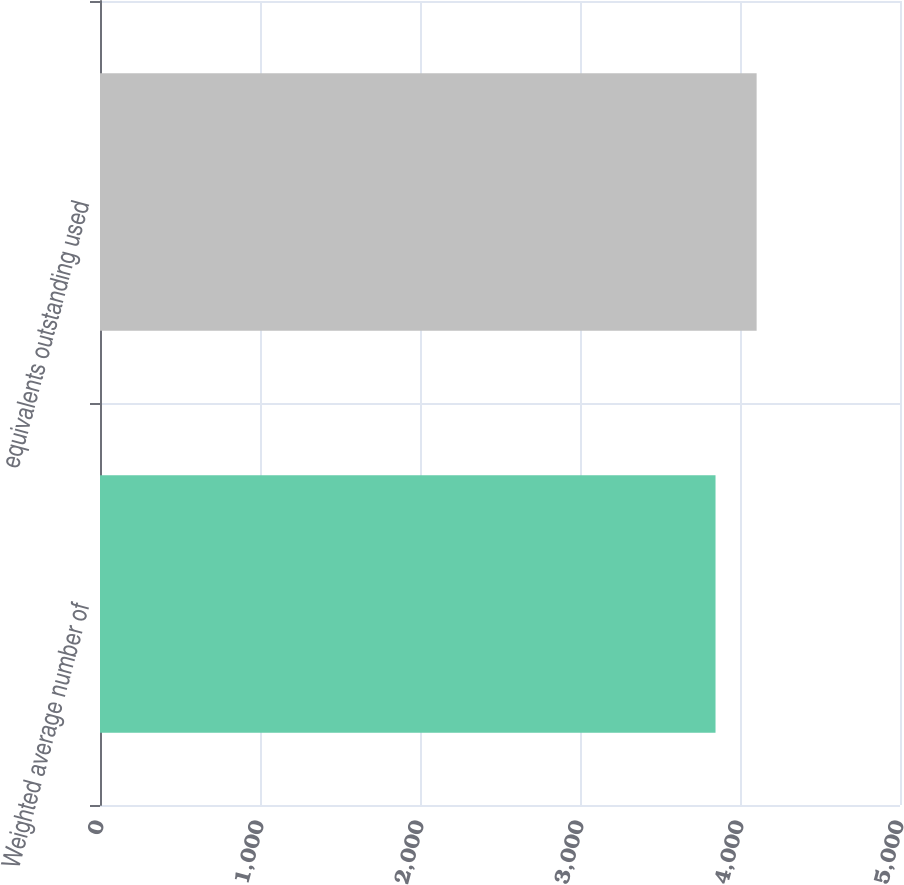Convert chart. <chart><loc_0><loc_0><loc_500><loc_500><bar_chart><fcel>Weighted average number of<fcel>equivalents outstanding used<nl><fcel>3847<fcel>4104<nl></chart> 